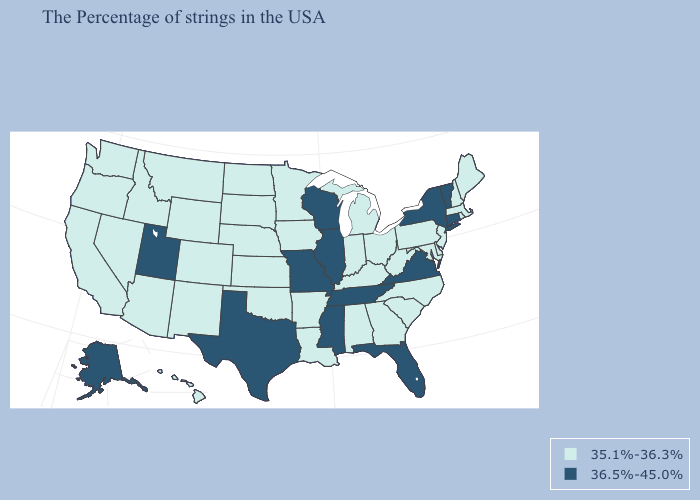Does Alaska have the highest value in the West?
Give a very brief answer. Yes. Name the states that have a value in the range 35.1%-36.3%?
Concise answer only. Maine, Massachusetts, Rhode Island, New Hampshire, New Jersey, Delaware, Maryland, Pennsylvania, North Carolina, South Carolina, West Virginia, Ohio, Georgia, Michigan, Kentucky, Indiana, Alabama, Louisiana, Arkansas, Minnesota, Iowa, Kansas, Nebraska, Oklahoma, South Dakota, North Dakota, Wyoming, Colorado, New Mexico, Montana, Arizona, Idaho, Nevada, California, Washington, Oregon, Hawaii. What is the lowest value in states that border Delaware?
Quick response, please. 35.1%-36.3%. What is the value of New Jersey?
Concise answer only. 35.1%-36.3%. Name the states that have a value in the range 36.5%-45.0%?
Answer briefly. Vermont, Connecticut, New York, Virginia, Florida, Tennessee, Wisconsin, Illinois, Mississippi, Missouri, Texas, Utah, Alaska. What is the value of Louisiana?
Write a very short answer. 35.1%-36.3%. Which states have the highest value in the USA?
Concise answer only. Vermont, Connecticut, New York, Virginia, Florida, Tennessee, Wisconsin, Illinois, Mississippi, Missouri, Texas, Utah, Alaska. What is the value of New Mexico?
Give a very brief answer. 35.1%-36.3%. Among the states that border Pennsylvania , which have the lowest value?
Answer briefly. New Jersey, Delaware, Maryland, West Virginia, Ohio. Name the states that have a value in the range 36.5%-45.0%?
Short answer required. Vermont, Connecticut, New York, Virginia, Florida, Tennessee, Wisconsin, Illinois, Mississippi, Missouri, Texas, Utah, Alaska. What is the value of Iowa?
Short answer required. 35.1%-36.3%. Among the states that border Kansas , does Nebraska have the highest value?
Quick response, please. No. Does the first symbol in the legend represent the smallest category?
Quick response, please. Yes. What is the highest value in the South ?
Write a very short answer. 36.5%-45.0%. 